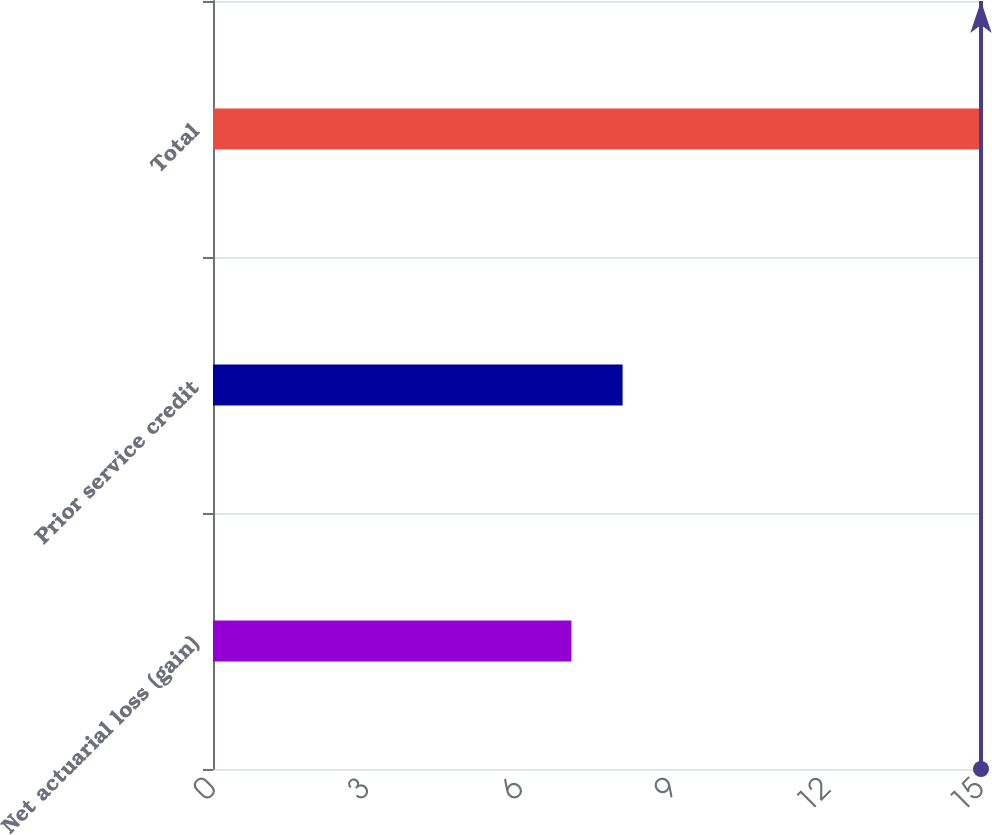Convert chart to OTSL. <chart><loc_0><loc_0><loc_500><loc_500><bar_chart><fcel>Net actuarial loss (gain)<fcel>Prior service credit<fcel>Total<nl><fcel>7<fcel>8<fcel>15<nl></chart> 